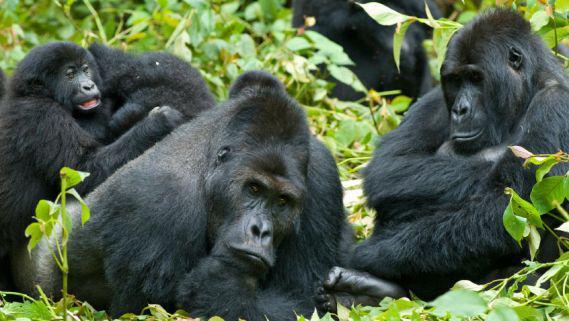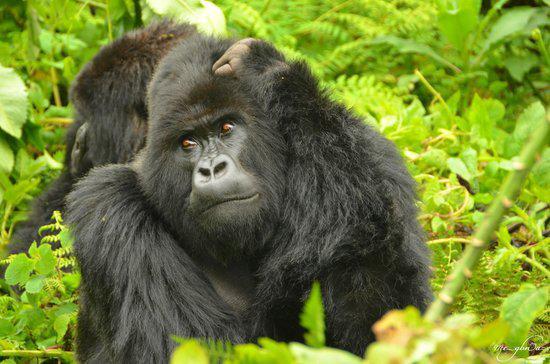The first image is the image on the left, the second image is the image on the right. Considering the images on both sides, is "A single primate is in the grass in each of the images." valid? Answer yes or no. No. The first image is the image on the left, the second image is the image on the right. Considering the images on both sides, is "The right image features an adult gorilla peering leftward with a closed mouth." valid? Answer yes or no. Yes. 